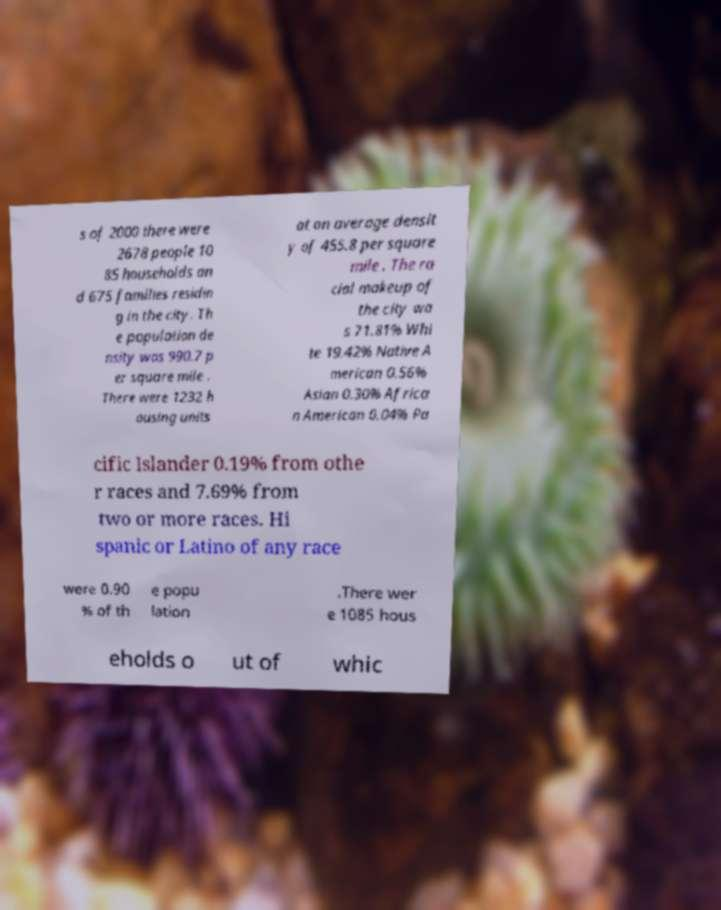I need the written content from this picture converted into text. Can you do that? s of 2000 there were 2678 people 10 85 households an d 675 families residin g in the city. Th e population de nsity was 990.7 p er square mile . There were 1232 h ousing units at an average densit y of 455.8 per square mile . The ra cial makeup of the city wa s 71.81% Whi te 19.42% Native A merican 0.56% Asian 0.30% Africa n American 0.04% Pa cific Islander 0.19% from othe r races and 7.69% from two or more races. Hi spanic or Latino of any race were 0.90 % of th e popu lation .There wer e 1085 hous eholds o ut of whic 